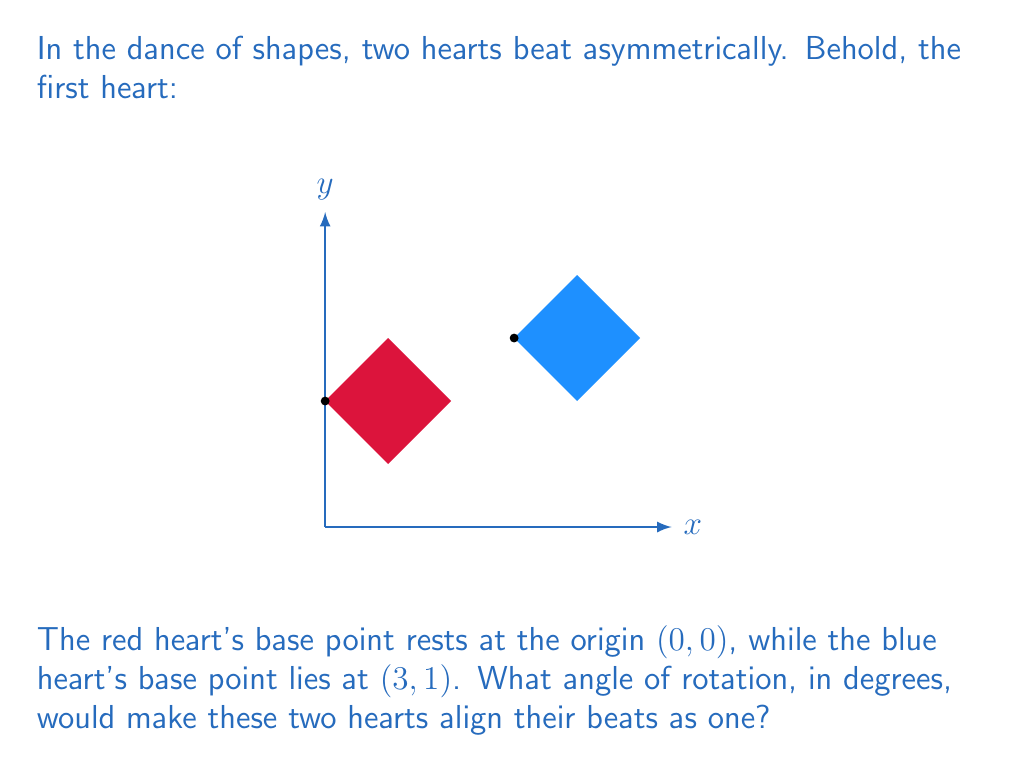Provide a solution to this math problem. Let's approach this poetic problem step-by-step, allowing our mathematical intuition to dance with the hearts:

1) To align the hearts, we need to rotate the blue heart around the origin until its base point coincides with the red heart's base point (0,0).

2) We can view this as rotating the point (3,1) to (0,0) around the origin.

3) The angle of rotation can be calculated using the arctangent function:
   $$\theta = \arctan(\frac{y}{x})$$
   Where (x,y) is the point to be rotated.

4) In our case, x = 3 and y = 1. Substituting these values:
   $$\theta = \arctan(\frac{1}{3})$$

5) Calculate this value:
   $$\theta \approx 0.3217 \text{ radians}$$

6) Convert radians to degrees:
   $$\theta_{degrees} = \theta_{radians} \cdot \frac{180°}{\pi}$$
   $$\theta_{degrees} \approx 0.3217 \cdot \frac{180°}{\pi} \approx 18.43°$$

7) However, this rotation would align the blue heart's base point with (0,0), but in the wrong direction. We need to rotate in the opposite direction, which means adding 180° to our result:
   $$\text{Final rotation} = 18.43° + 180° = 198.43°$$

8) Rounding to the nearest degree for simplicity:
   $$\text{Final rotation} \approx 198°$$

Thus, a rotation of approximately 198° clockwise (or 162° counterclockwise) would align the two hearts, synchronizing their asymmetrical beats.
Answer: 198° 